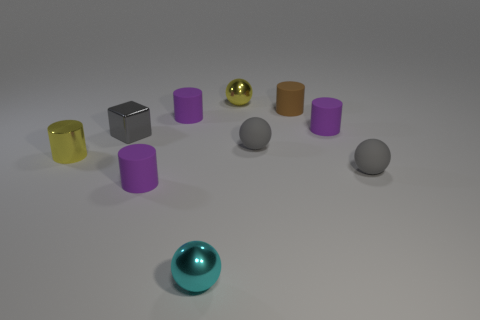How many purple cylinders must be subtracted to get 1 purple cylinders? 2 Subtract all yellow blocks. How many purple cylinders are left? 3 Subtract all brown matte cylinders. How many cylinders are left? 4 Subtract all brown cylinders. How many cylinders are left? 4 Subtract all green cylinders. Subtract all purple balls. How many cylinders are left? 5 Subtract all balls. How many objects are left? 6 Add 2 small gray shiny blocks. How many small gray shiny blocks are left? 3 Add 2 small cyan things. How many small cyan things exist? 3 Subtract 0 blue cylinders. How many objects are left? 10 Subtract all small yellow metallic things. Subtract all cyan metal objects. How many objects are left? 7 